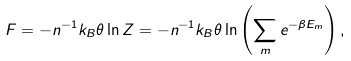<formula> <loc_0><loc_0><loc_500><loc_500>F = - n ^ { - 1 } k _ { B } \theta \ln Z = - n ^ { - 1 } k _ { B } \theta \ln \left ( \sum _ { m } e ^ { - \beta E _ { m } } \right ) ,</formula> 